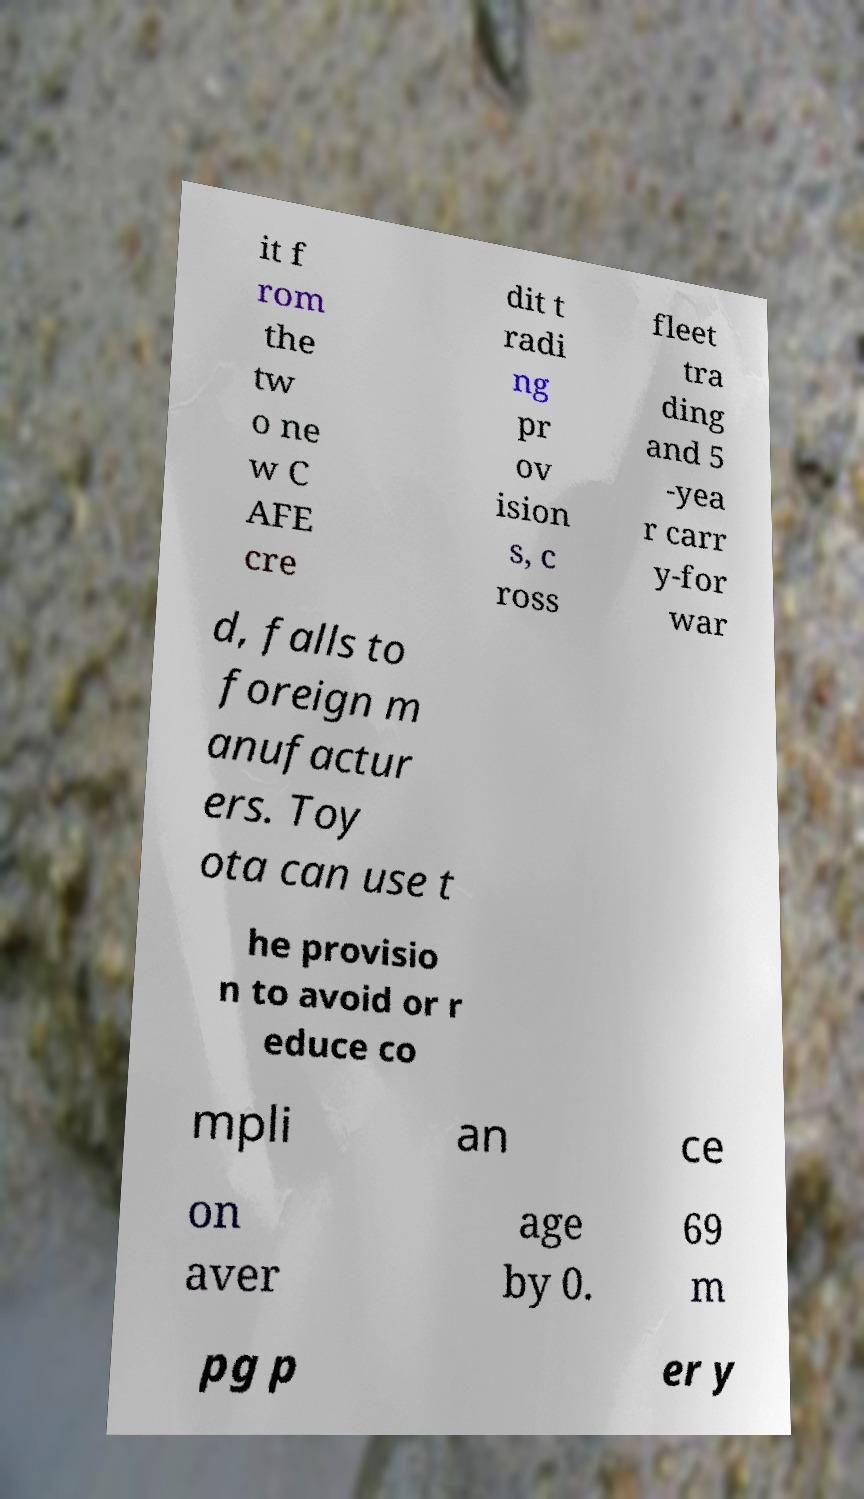Can you read and provide the text displayed in the image?This photo seems to have some interesting text. Can you extract and type it out for me? it f rom the tw o ne w C AFE cre dit t radi ng pr ov ision s, c ross fleet tra ding and 5 -yea r carr y-for war d, falls to foreign m anufactur ers. Toy ota can use t he provisio n to avoid or r educe co mpli an ce on aver age by 0. 69 m pg p er y 